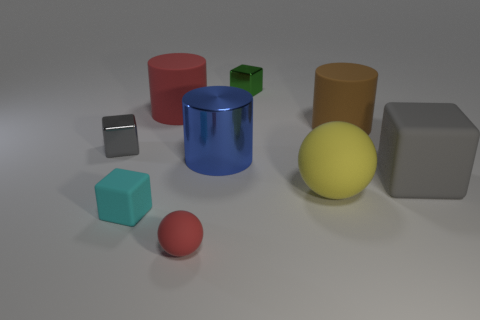Can you tell me something about the texture of the surfaces? Certainly, the objects display a variety of textures. The blue cylinder and the red round-edged cylinder exhibit a shiny, reflective texture, contrasting with the matte finish of the other objects. The yellow sphere and teal cube appear to have a smooth surface, while the green cube has a slightly textured surface that may suggest a granular feel. The gray forms have a non-reflective, even texture that diffuses light softly. 